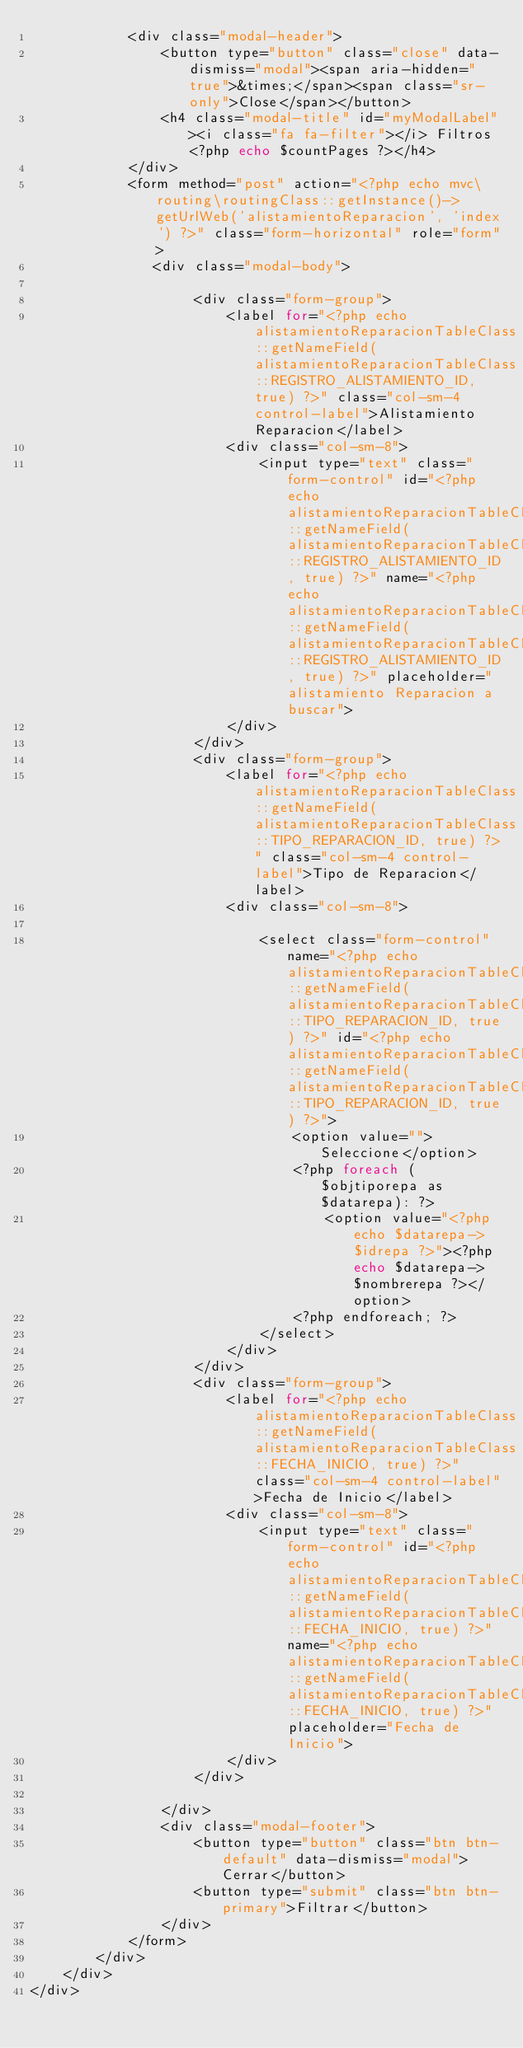<code> <loc_0><loc_0><loc_500><loc_500><_PHP_>            <div class="modal-header">
                <button type="button" class="close" data-dismiss="modal"><span aria-hidden="true">&times;</span><span class="sr-only">Close</span></button>
                <h4 class="modal-title" id="myModalLabel"><i class="fa fa-filter"></i> Filtros <?php echo $countPages ?></h4>
            </div>
            <form method="post" action="<?php echo mvc\routing\routingClass::getInstance()->getUrlWeb('alistamientoReparacion', 'index') ?>" class="form-horizontal" role="form">
               <div class="modal-body">

                    <div class="form-group">
                        <label for="<?php echo alistamientoReparacionTableClass::getNameField(alistamientoReparacionTableClass::REGISTRO_ALISTAMIENTO_ID, true) ?>" class="col-sm-4 control-label">Alistamiento Reparacion</label>
                        <div class="col-sm-8">
                            <input type="text" class="form-control" id="<?php echo alistamientoReparacionTableClass::getNameField(alistamientoReparacionTableClass::REGISTRO_ALISTAMIENTO_ID, true) ?>" name="<?php echo alistamientoReparacionTableClass::getNameField(alistamientoReparacionTableClass::REGISTRO_ALISTAMIENTO_ID, true) ?>" placeholder="alistamiento Reparacion a buscar">
                        </div>
                    </div>
                    <div class="form-group">
                        <label for="<?php echo alistamientoReparacionTableClass::getNameField(alistamientoReparacionTableClass::TIPO_REPARACION_ID, true) ?>" class="col-sm-4 control-label">Tipo de Reparacion</label>
                        <div class="col-sm-8">

                            <select class="form-control" name="<?php echo alistamientoReparacionTableClass::getNameField(alistamientoReparacionTableClass::TIPO_REPARACION_ID, true) ?>" id="<?php echo alistamientoReparacionTableClass::getNameField(alistamientoReparacionTableClass::TIPO_REPARACION_ID, true) ?>">
                                <option value="">Seleccione</option>
                                <?php foreach ($objtiporepa as $datarepa): ?>
                                    <option value="<?php echo $datarepa->$idrepa ?>"><?php echo $datarepa->$nombrerepa ?></option>
                                <?php endforeach; ?>
                            </select>
                        </div>
                    </div>
                    <div class="form-group">
                        <label for="<?php echo alistamientoReparacionTableClass::getNameField(alistamientoReparacionTableClass::FECHA_INICIO, true) ?>" class="col-sm-4 control-label">Fecha de Inicio</label>
                        <div class="col-sm-8">
                            <input type="text" class="form-control" id="<?php echo alistamientoReparacionTableClass::getNameField(alistamientoReparacionTableClass::FECHA_INICIO, true) ?>" name="<?php echo alistamientoReparacionTableClass::getNameField(alistamientoReparacionTableClass::FECHA_INICIO, true) ?>" placeholder="Fecha de Inicio">
                        </div>
                    </div>

                </div>
                <div class="modal-footer">
                    <button type="button" class="btn btn-default" data-dismiss="modal">Cerrar</button>
                    <button type="submit" class="btn btn-primary">Filtrar</button>
                </div>
            </form>
        </div>
    </div>
</div></code> 